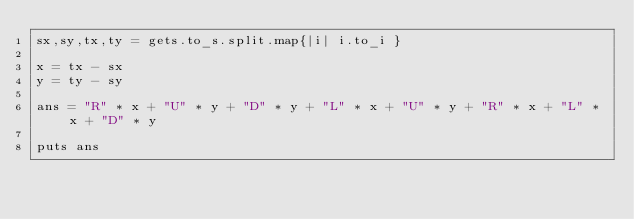Convert code to text. <code><loc_0><loc_0><loc_500><loc_500><_Crystal_>sx,sy,tx,ty = gets.to_s.split.map{|i| i.to_i }

x = tx - sx
y = ty - sy

ans = "R" * x + "U" * y + "D" * y + "L" * x + "U" * y + "R" * x + "L" * x + "D" * y

puts ans</code> 